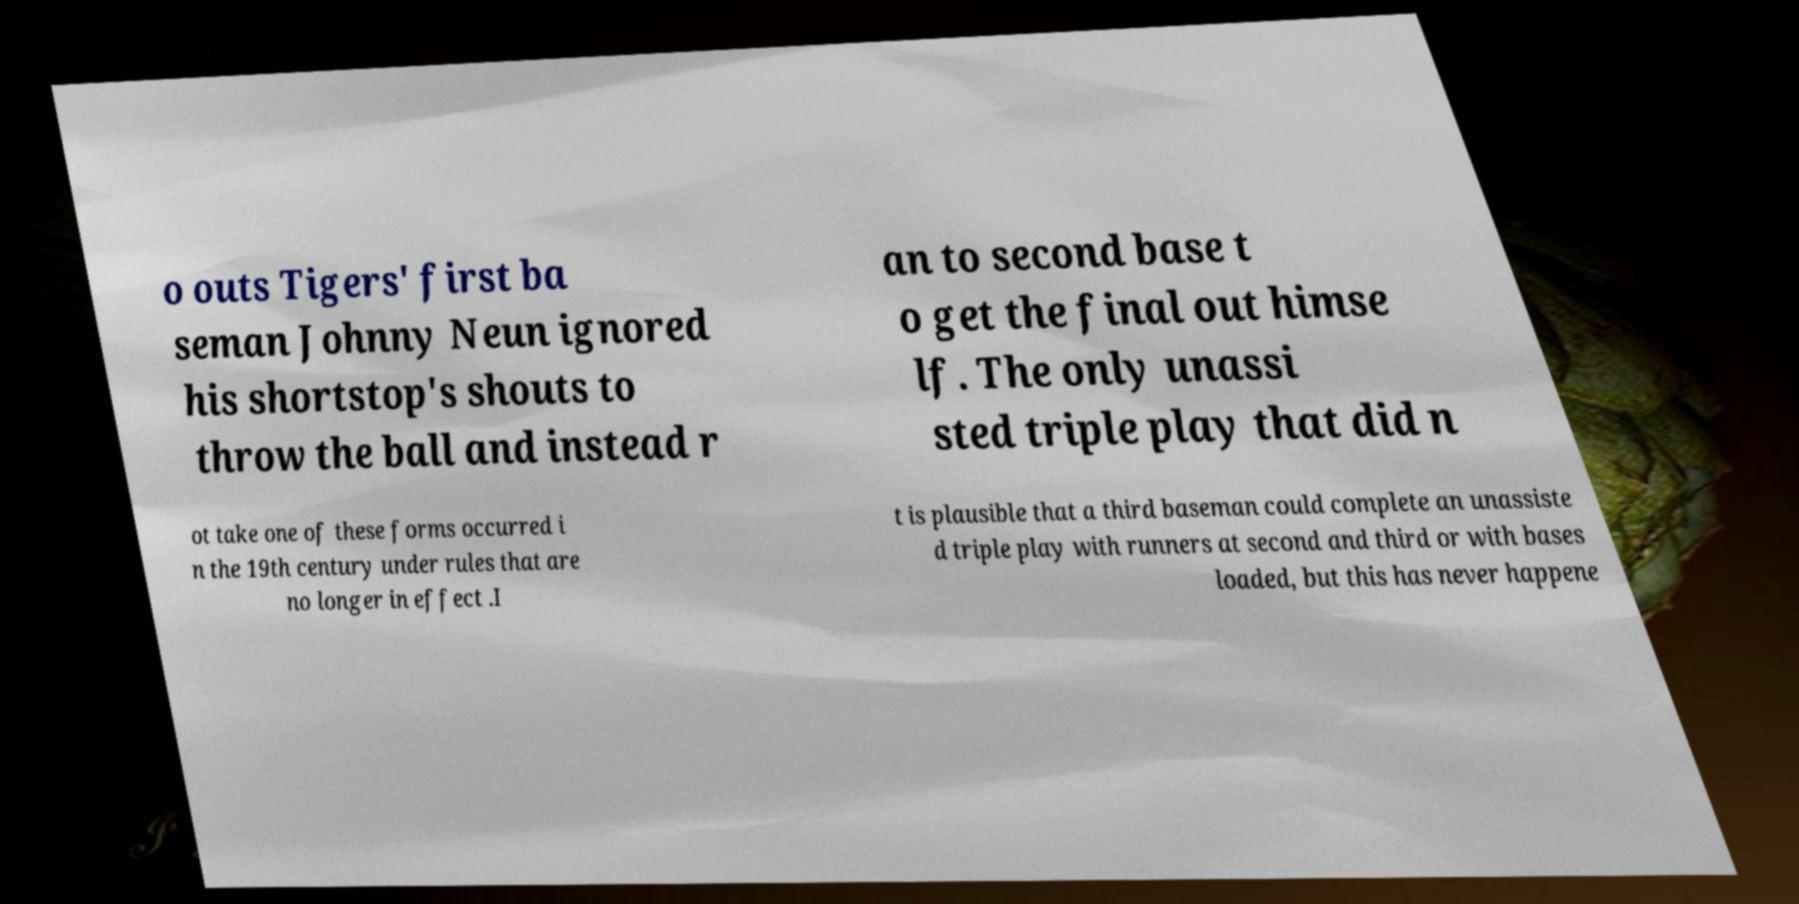For documentation purposes, I need the text within this image transcribed. Could you provide that? o outs Tigers' first ba seman Johnny Neun ignored his shortstop's shouts to throw the ball and instead r an to second base t o get the final out himse lf. The only unassi sted triple play that did n ot take one of these forms occurred i n the 19th century under rules that are no longer in effect .I t is plausible that a third baseman could complete an unassiste d triple play with runners at second and third or with bases loaded, but this has never happene 